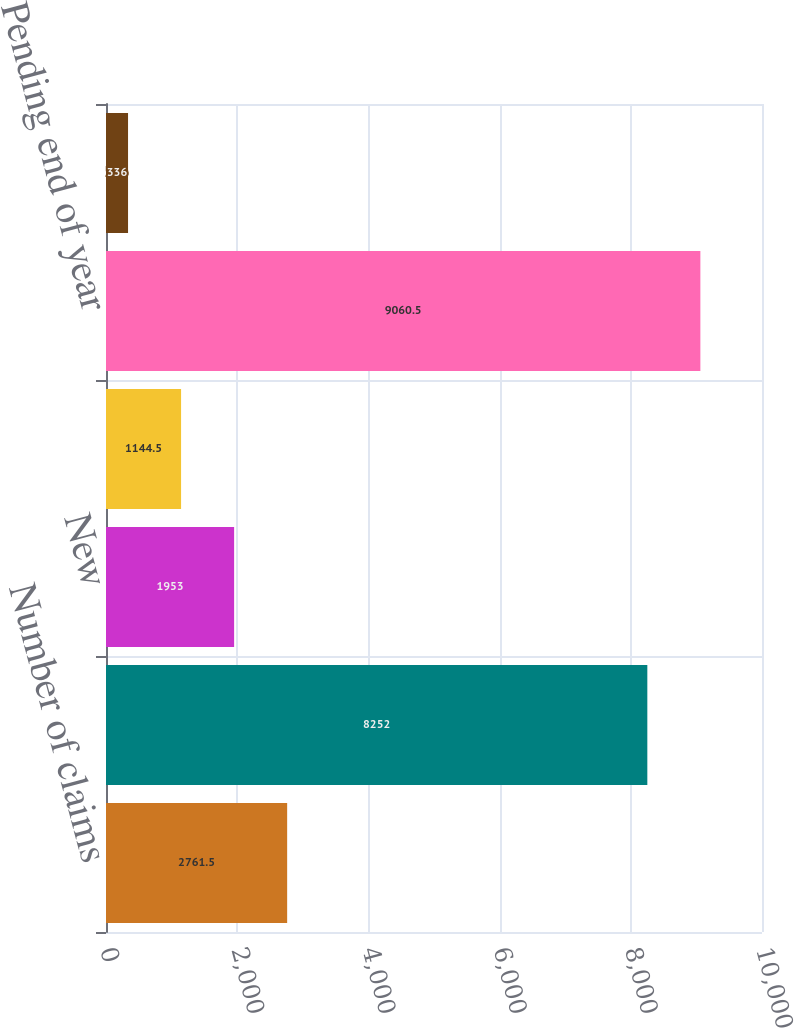<chart> <loc_0><loc_0><loc_500><loc_500><bar_chart><fcel>Number of claims<fcel>Pending beginning of year<fcel>New<fcel>Total closed<fcel>Pending end of year<fcel>Closed without payment<nl><fcel>2761.5<fcel>8252<fcel>1953<fcel>1144.5<fcel>9060.5<fcel>336<nl></chart> 